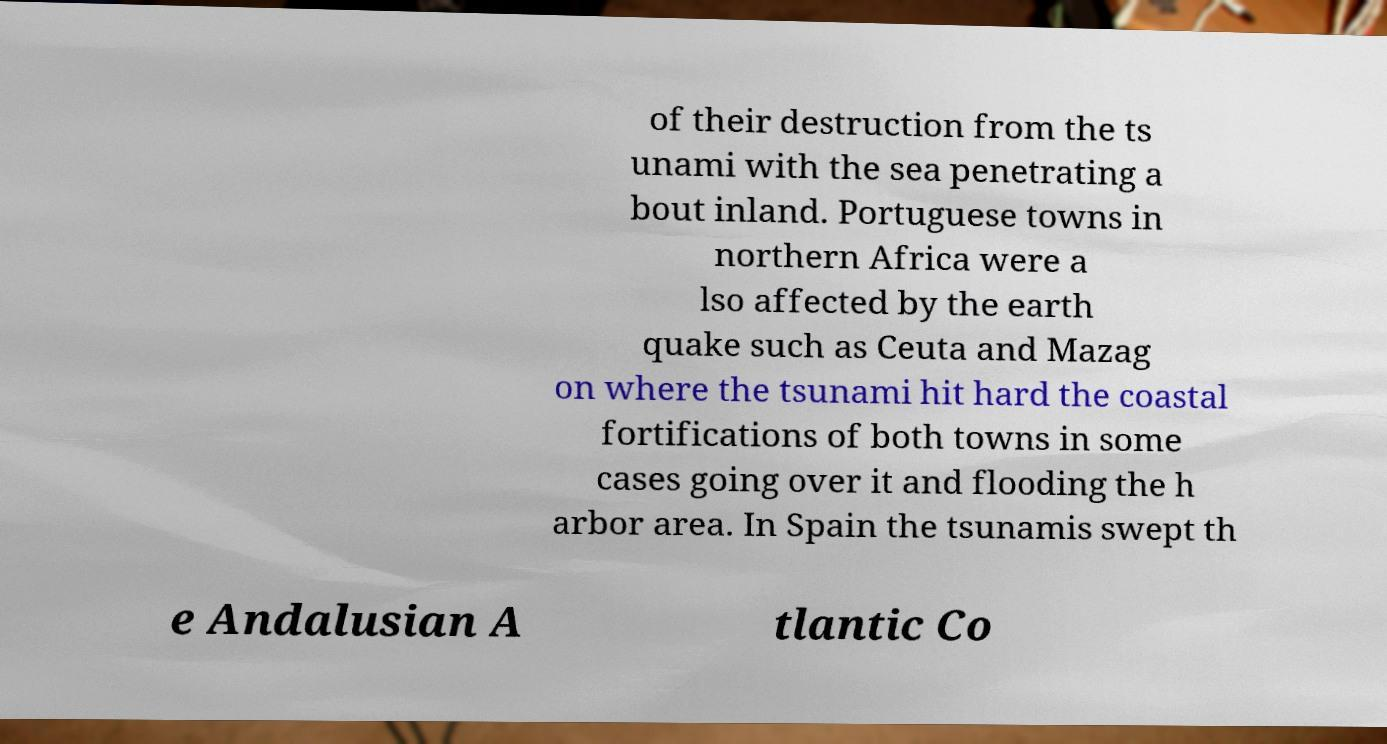For documentation purposes, I need the text within this image transcribed. Could you provide that? of their destruction from the ts unami with the sea penetrating a bout inland. Portuguese towns in northern Africa were a lso affected by the earth quake such as Ceuta and Mazag on where the tsunami hit hard the coastal fortifications of both towns in some cases going over it and flooding the h arbor area. In Spain the tsunamis swept th e Andalusian A tlantic Co 